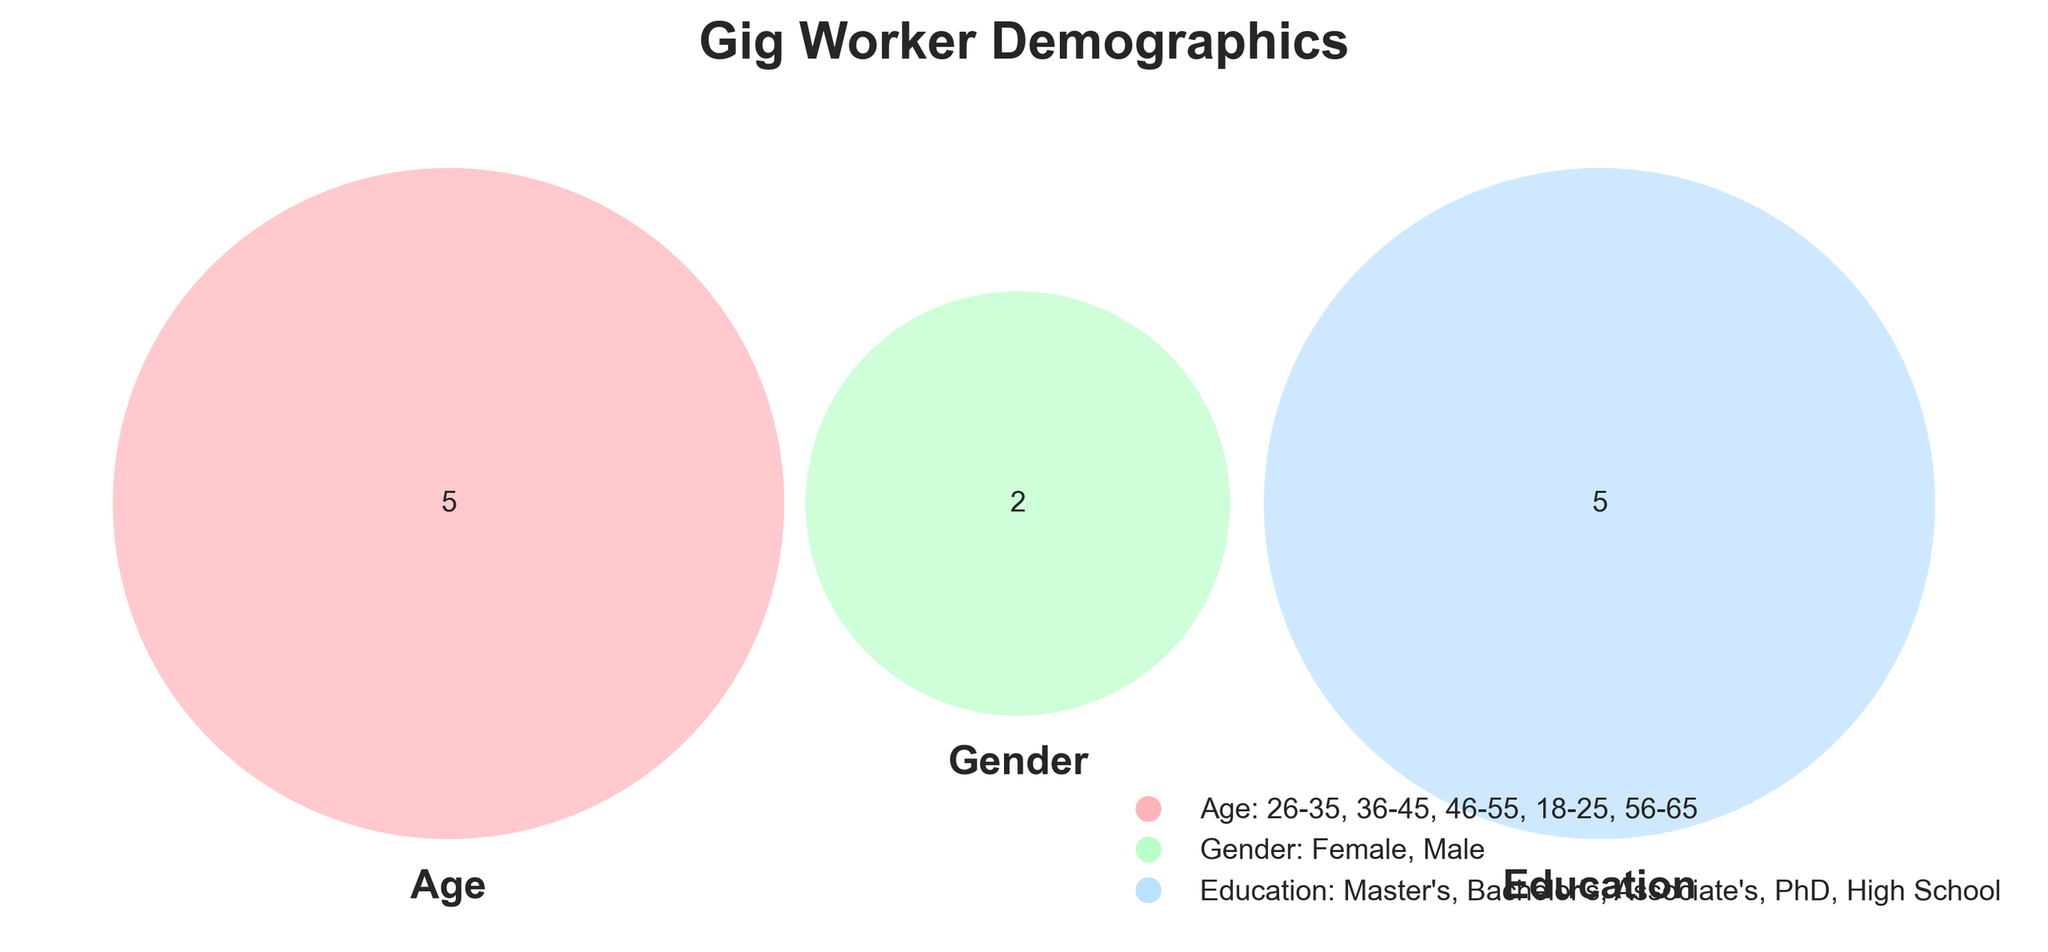What is the title of the plot? The title of the plot is shown at the top and reads "Gig Worker Demographics" in bold, large font.
Answer: Gig Worker Demographics What colors are used to represent the Age, Gender, and Education groups? The colors used are pink (#FFB3BA) for Age, light green (#BAFFC9) for Gender, and light blue (#BAE1FF) for Education, as indicated by legend elements.
Answer: Pink, light green, light blue How many unique age groups are represented in the Venn diagram? The legend elements indicate that there are five unique age groups. Each age group is listed individually.
Answer: 5 Which set has the highest number of unique values: Age, Gender, or Education? By counting the unique values listed in the legend elements, Age and Education each have five unique values, while Gender has two.
Answer: Age and Education Does any intersection in the Venn diagram represent all three sets (Age, Gender, and Education)? Reviewing the Venn diagram, locate any regions where all three sets overlap; this is represented by the central part of the three circles.
Answer: Yes What age groups fall into the intersection of Age and Gender sets? By reviewing the overlaps between Age and Gender segments in the Venn diagram and consulting the legend to discern these groups.
Answer: 18-25, 26-35, 36-45, 46-55, 56-65 Which group has more unique values, Education or Gender? The legend indicates that Education has five unique values listed, while Gender has two unique values.
Answer: Education Are there more workers with a Bachelor's degree or a Master's degree? From Education values in the legend, compare counts of "Bachelor's" and "Master's." Given number of values, check intersections involving these levels.
Answer: Equal What intersection areas exist between Education and Gender? Examine the Venn diagram for overlapping sections between Education and Gender circles, consulting the legend to understand these overlaps.
Answer: 5 (overlapping for Bachelor's, Master's, Associate's, PhD) 